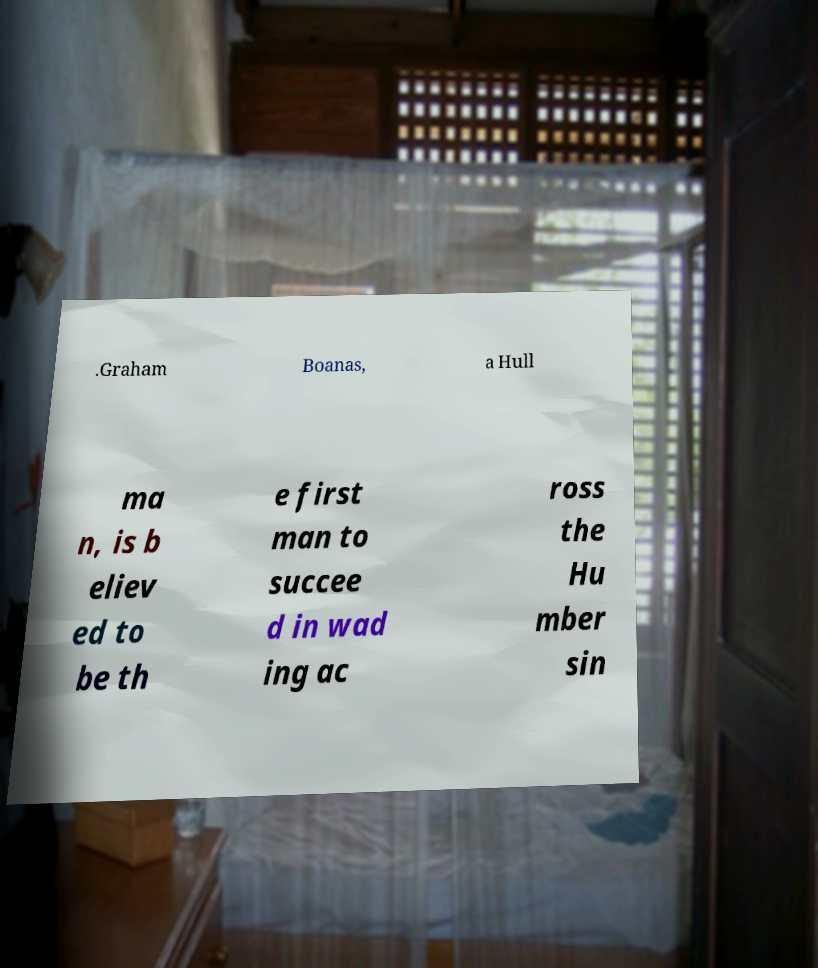Can you accurately transcribe the text from the provided image for me? .Graham Boanas, a Hull ma n, is b eliev ed to be th e first man to succee d in wad ing ac ross the Hu mber sin 